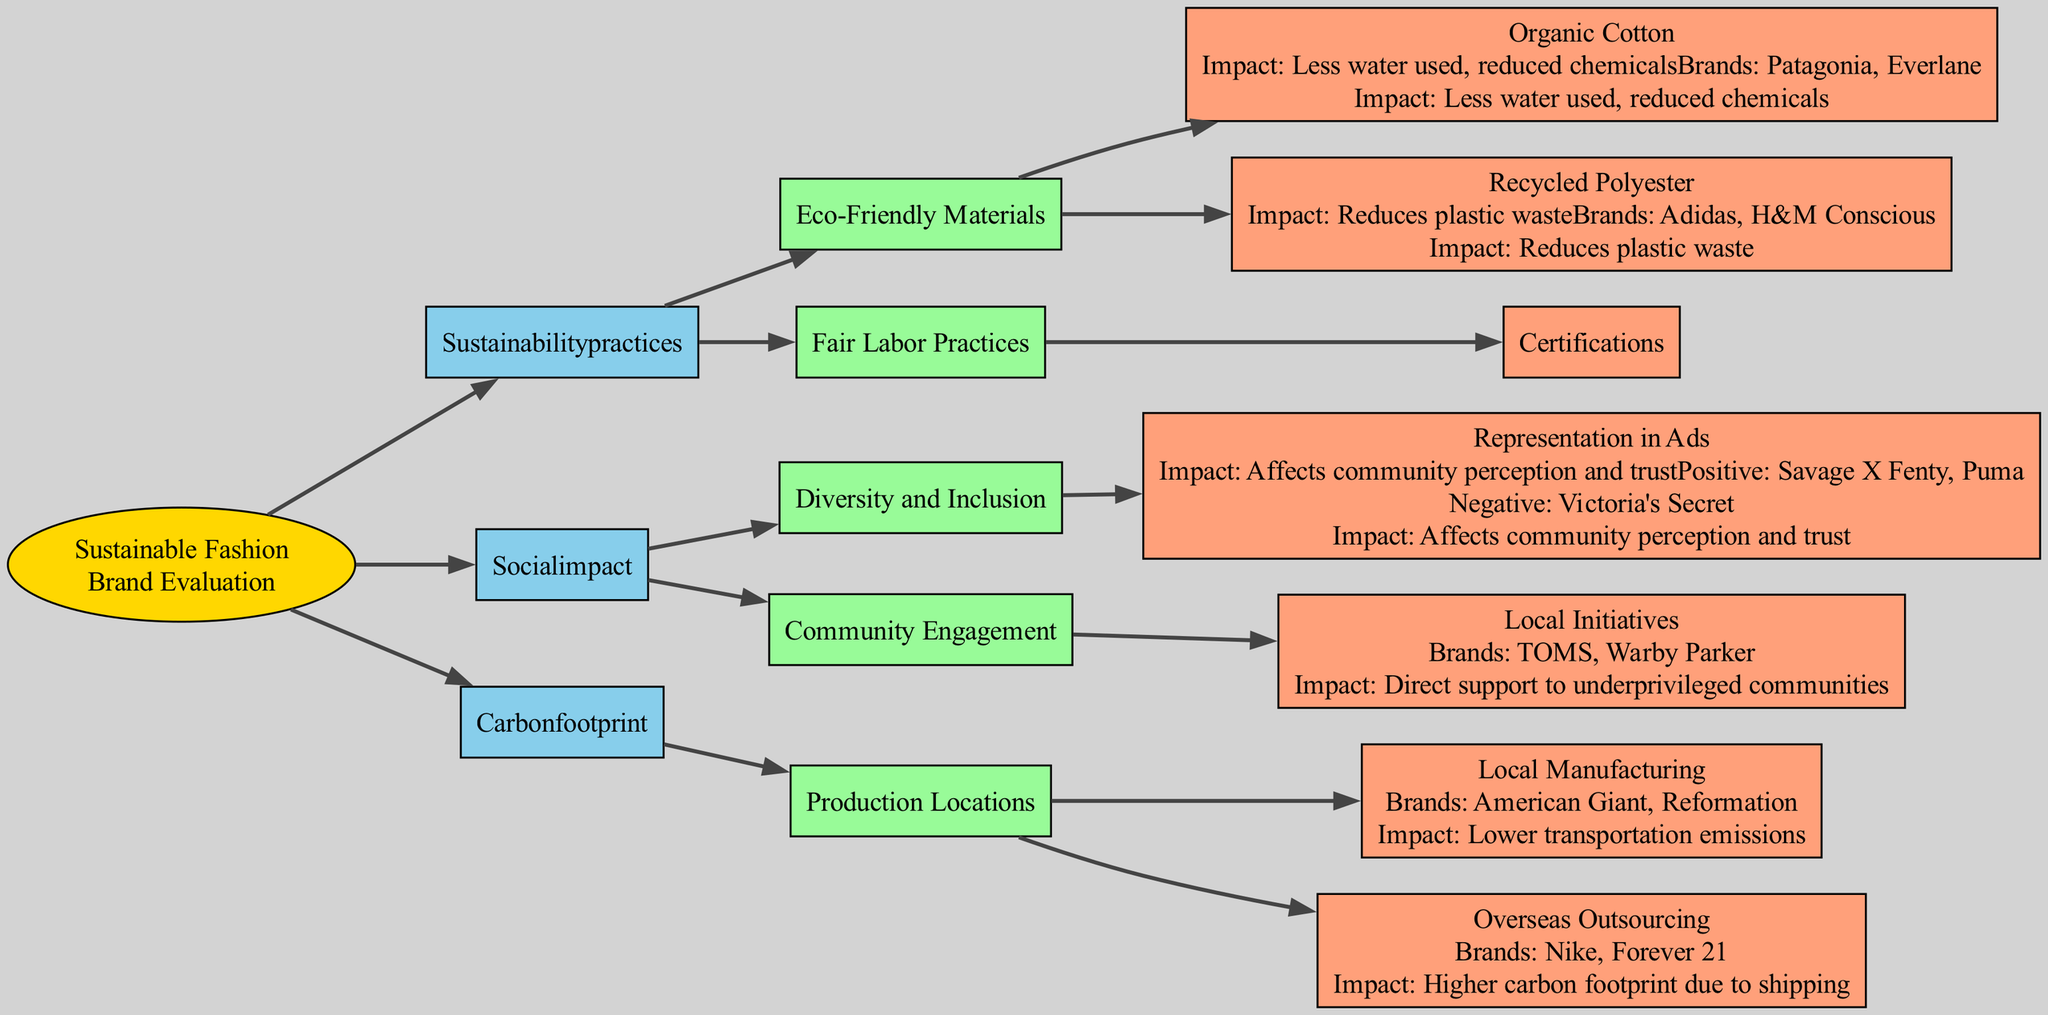What brands are associated with Organic Cotton? According to the diagram, the brands listed under Organic Cotton belong to the category of Eco-Friendly Materials. They are specified as Patagonia and Everlane, which indicates their sustainable material usage.
Answer: Patagonia, Everlane Which certification guarantees fair wages for workers? From the Fair Labor Practices section in the diagram, Fair Trade is identified as a certification that ensures workers receive fair wages. This encompasses a significant ethical consideration in fashion brands.
Answer: Fair Trade What are the positive examples for representation in ads? Within the Diversity and Inclusion criteria, the diagram lists Savage X Fenty and Puma as positive examples of representation in advertisements. This highlights their commitment to diversity.
Answer: Savage X Fenty, Puma How do local manufacturing brands impact transportation emissions? The diagram outlines that brands specializing in local manufacturing, such as American Giant and Reformation, significantly lower transportation emissions, which is beneficial for sustainability efforts.
Answer: Lower transportation emissions Which brands belong to the Recycled Polyester category? The diagram details that Adidas and H&M Conscious are the brands that utilize Recycled Polyester. This material choice aligns with sustainable practices by reducing plastic waste.
Answer: Adidas, H&M Conscious What is the impact of global Organic Textile Standard (GOTS)? Under Fair Labor Practices, the diagram notes that brands associated with GOTS, such as Thought Clothing and People Tree, engage in eco-friendly and ethical processes, which positively influences the environment and labor standards.
Answer: Eco-friendly and ethical processes What brands support underprivileged communities through local initiatives? The Community Engagement section specifies that brands TOMS and Warby Parker contribute to supporting underprivileged communities by actively engaging in local initiatives.
Answer: TOMS, Warby Parker Which brands have a higher carbon footprint? In the carbon footprint section, the diagram indicates that Nike and Forever 21 are associated with overseas outsourcing, leading to a higher carbon footprint due to the shipping involved in their products.
Answer: Nike, Forever 21 What is the impact of representation in ads on community trust? The diagram emphasizes that representation in advertisements can significantly affect community perception and trust, suggesting that brands' representation choices are integral to their societal impact.
Answer: Affects community perception and trust 